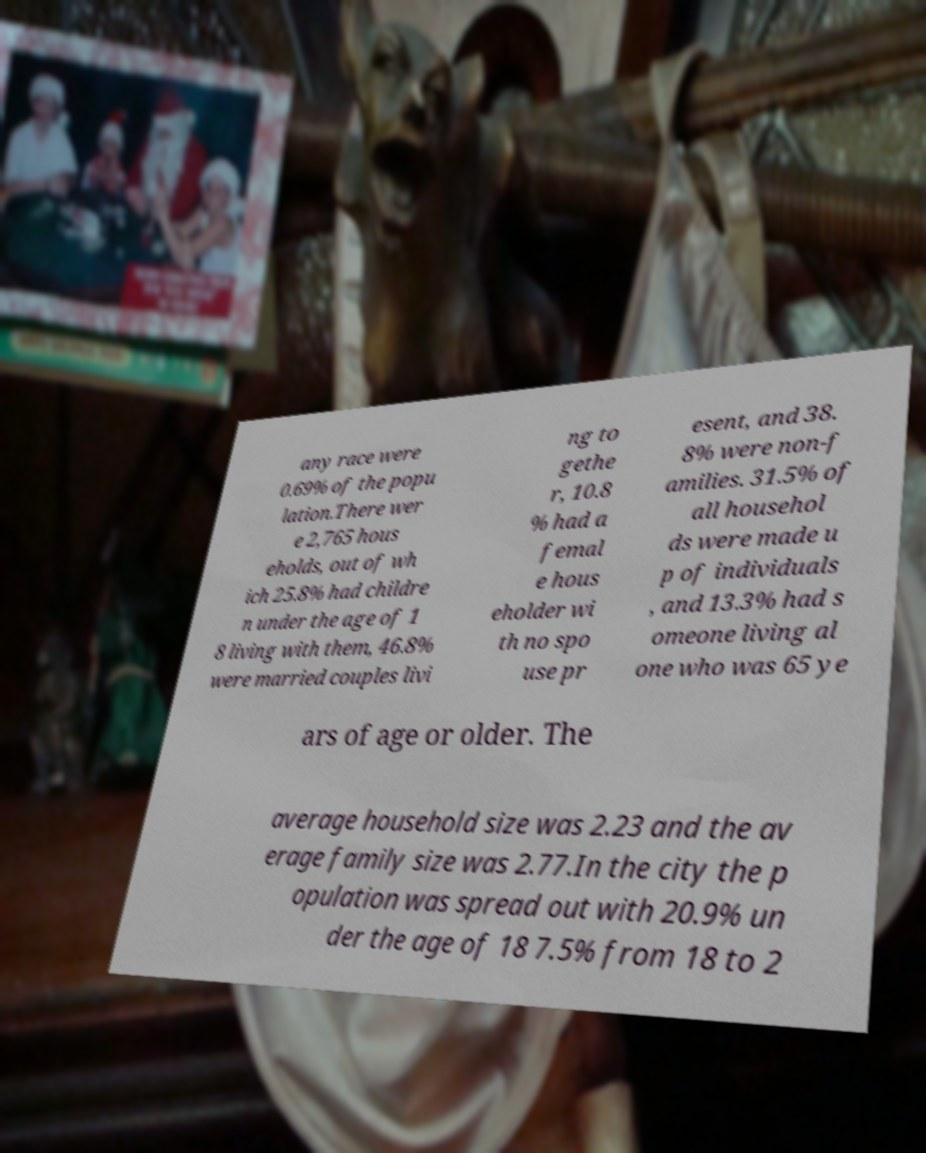Please read and relay the text visible in this image. What does it say? any race were 0.69% of the popu lation.There wer e 2,765 hous eholds, out of wh ich 25.8% had childre n under the age of 1 8 living with them, 46.8% were married couples livi ng to gethe r, 10.8 % had a femal e hous eholder wi th no spo use pr esent, and 38. 8% were non-f amilies. 31.5% of all househol ds were made u p of individuals , and 13.3% had s omeone living al one who was 65 ye ars of age or older. The average household size was 2.23 and the av erage family size was 2.77.In the city the p opulation was spread out with 20.9% un der the age of 18 7.5% from 18 to 2 